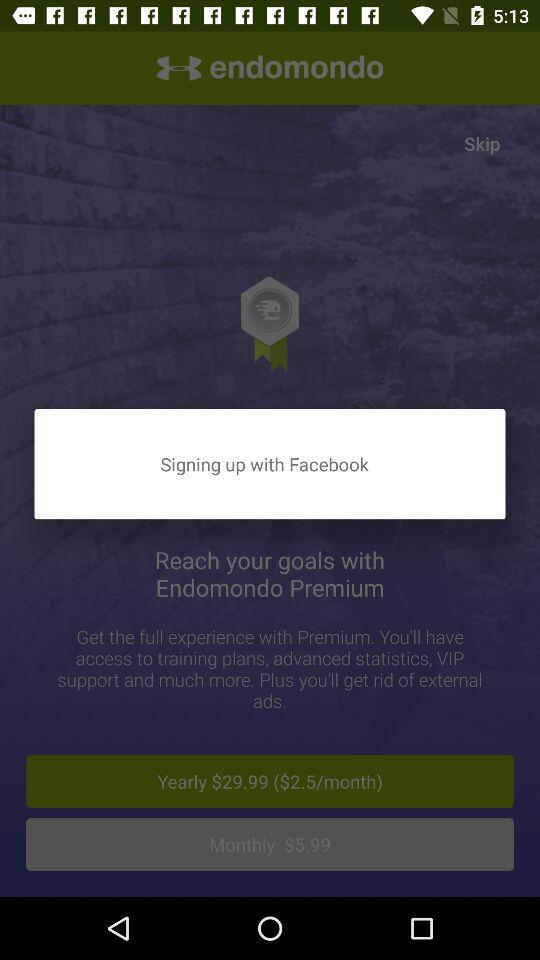Which subscription option is selected?
When the provided information is insufficient, respond with <no answer>. <no answer> 